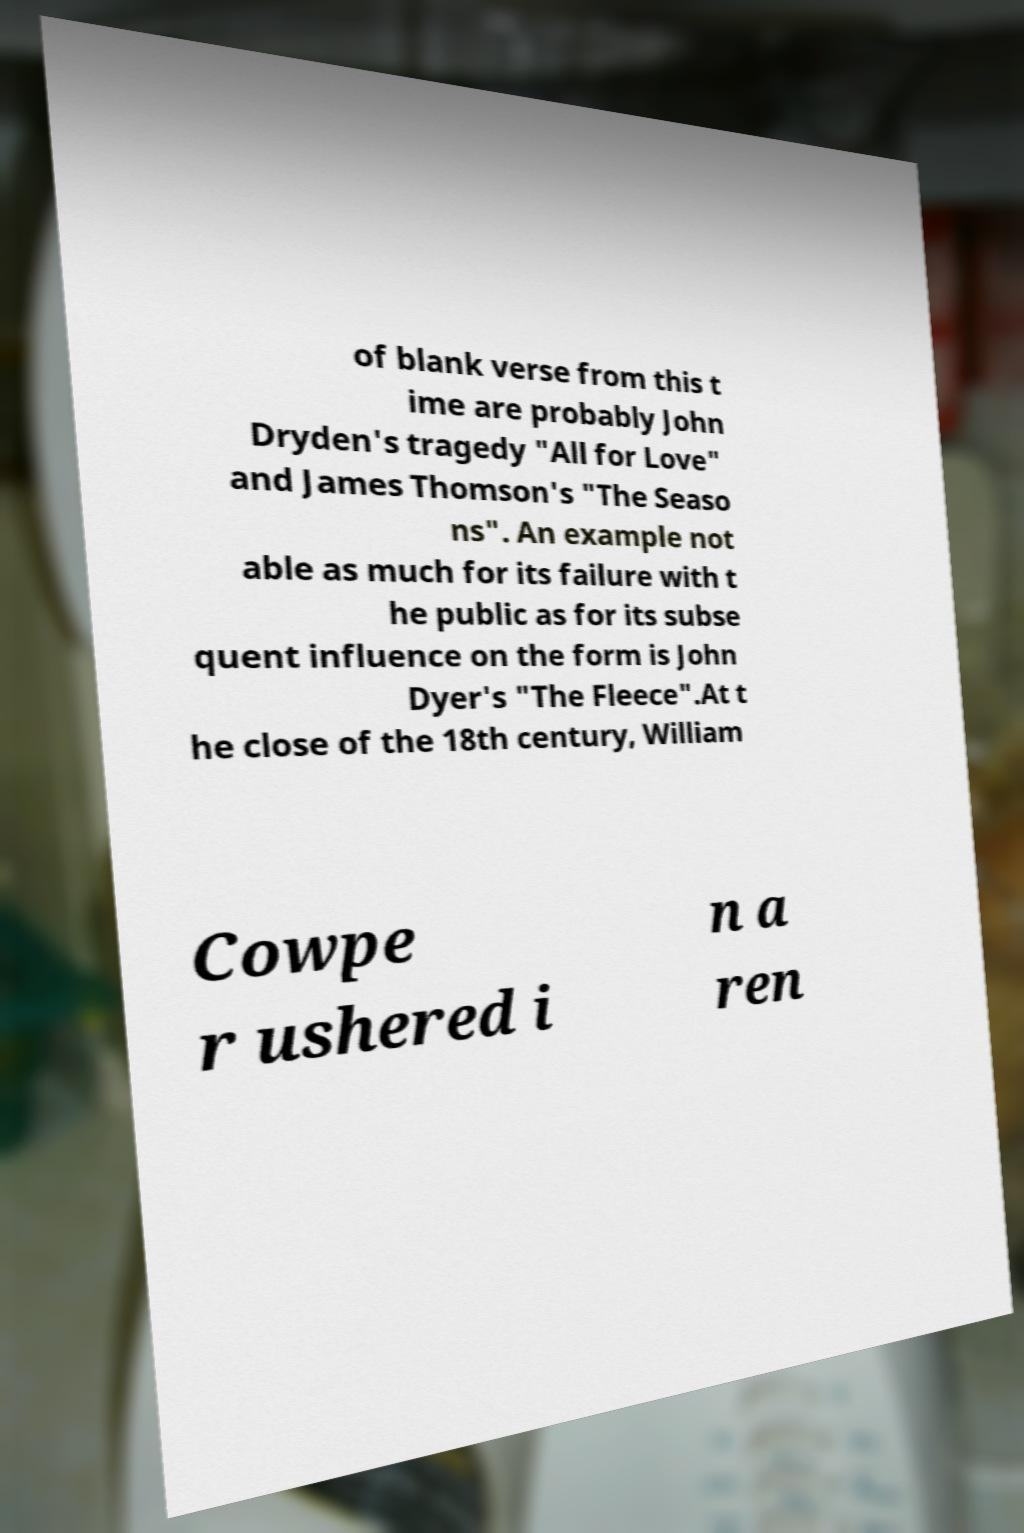Can you accurately transcribe the text from the provided image for me? of blank verse from this t ime are probably John Dryden's tragedy "All for Love" and James Thomson's "The Seaso ns". An example not able as much for its failure with t he public as for its subse quent influence on the form is John Dyer's "The Fleece".At t he close of the 18th century, William Cowpe r ushered i n a ren 